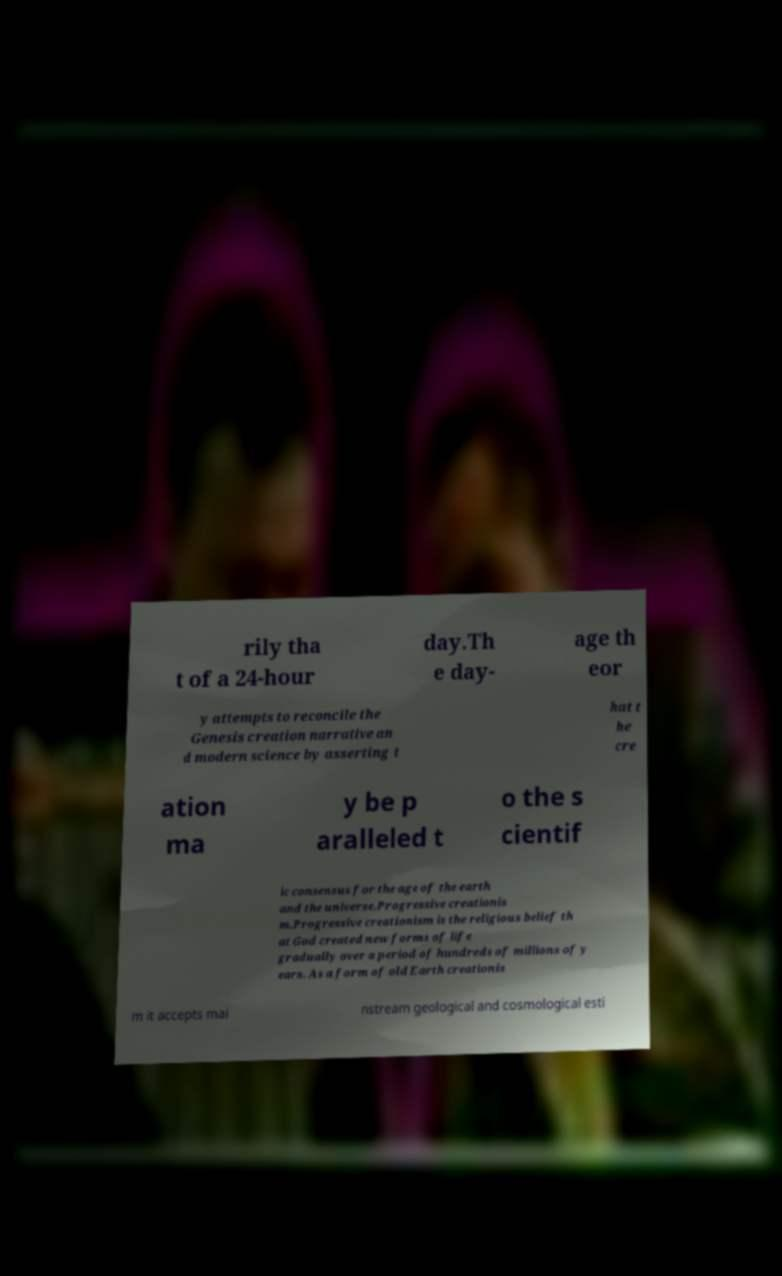Can you accurately transcribe the text from the provided image for me? rily tha t of a 24-hour day.Th e day- age th eor y attempts to reconcile the Genesis creation narrative an d modern science by asserting t hat t he cre ation ma y be p aralleled t o the s cientif ic consensus for the age of the earth and the universe.Progressive creationis m.Progressive creationism is the religious belief th at God created new forms of life gradually over a period of hundreds of millions of y ears. As a form of old Earth creationis m it accepts mai nstream geological and cosmological esti 